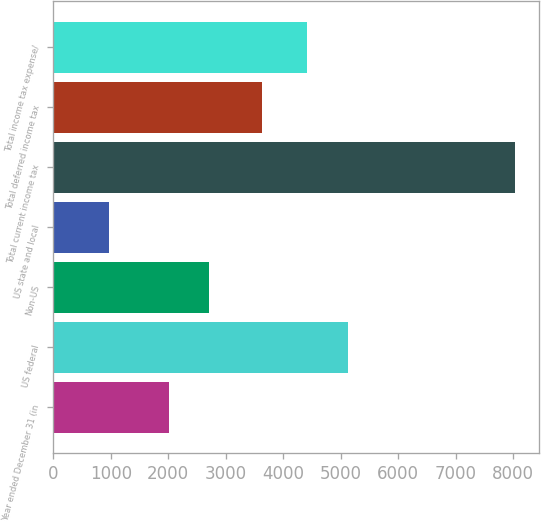<chart> <loc_0><loc_0><loc_500><loc_500><bar_chart><fcel>Year ended December 31 (in<fcel>US federal<fcel>Non-US<fcel>US state and local<fcel>Total current income tax<fcel>Total deferred income tax<fcel>Total income tax expense/<nl><fcel>2009<fcel>5121.6<fcel>2715.6<fcel>971<fcel>8037<fcel>3622<fcel>4415<nl></chart> 